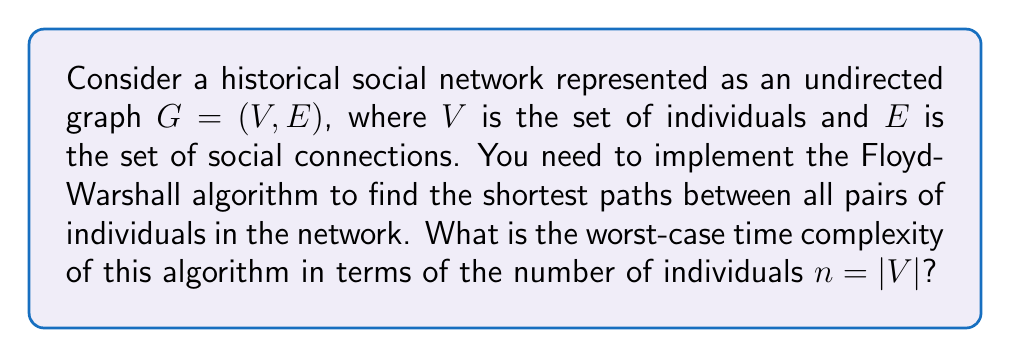Can you answer this question? To analyze the time complexity of the Floyd-Warshall algorithm for a historical social network, we need to consider the following steps:

1. The Floyd-Warshall algorithm is used to find the shortest paths between all pairs of vertices in a weighted graph. In this case, our graph represents a social network where the weights could represent the strength or closeness of relationships.

2. The algorithm uses a dynamic programming approach and consists of three nested loops:

   ```
   for k = 1 to n
       for i = 1 to n
           for j = 1 to n
               dist[i][j] = min(dist[i][j], dist[i][k] + dist[k][j])
   ```

3. Each of these loops iterates $n$ times, where $n$ is the number of vertices (individuals) in the graph.

4. Inside the innermost loop, we perform a constant number of operations (comparison and addition).

5. To determine the time complexity, we count the total number of constant-time operations:

   $$T(n) = n \cdot n \cdot n \cdot O(1) = O(n^3)$$

6. This cubic time complexity $O(n^3)$ represents the worst-case scenario, which occurs when the graph is dense (i.e., many connections between individuals).

7. It's worth noting that for sparse graphs, which might be more common in certain historical social networks, there exist more efficient algorithms. However, the Floyd-Warshall algorithm's simplicity and ability to handle negative weights (if applicable to your historical data analysis) make it a valuable tool in some scenarios.

8. The space complexity of the algorithm is $O(n^2)$ to store the distance matrix, which might be a consideration when dealing with very large historical networks.
Answer: The worst-case time complexity of the Floyd-Warshall algorithm for analyzing a historical social network with $n$ individuals is $O(n^3)$. 